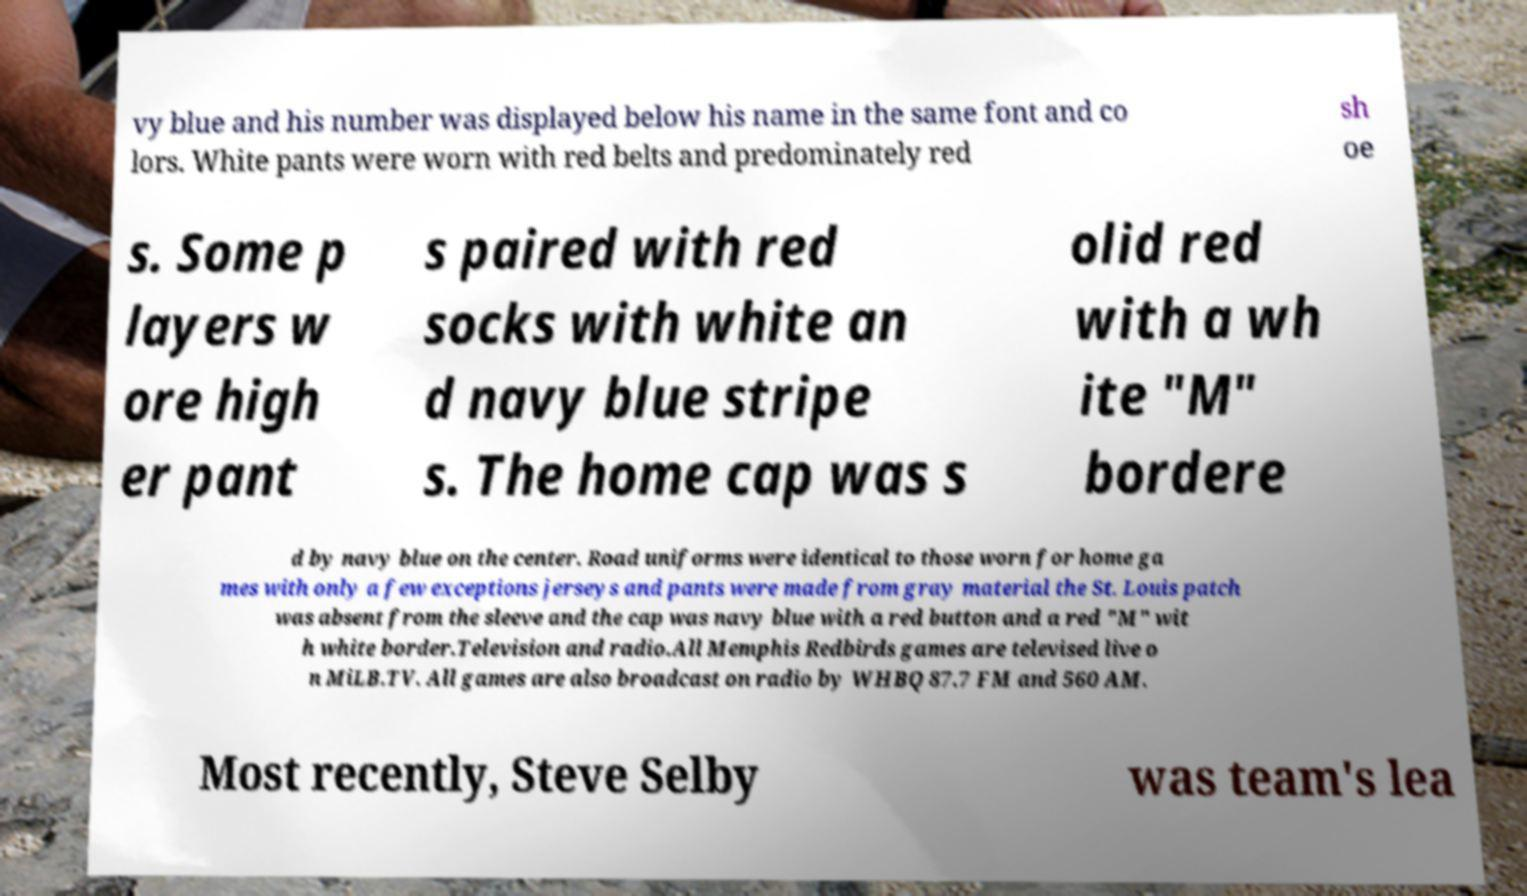Can you read and provide the text displayed in the image?This photo seems to have some interesting text. Can you extract and type it out for me? vy blue and his number was displayed below his name in the same font and co lors. White pants were worn with red belts and predominately red sh oe s. Some p layers w ore high er pant s paired with red socks with white an d navy blue stripe s. The home cap was s olid red with a wh ite "M" bordere d by navy blue on the center. Road uniforms were identical to those worn for home ga mes with only a few exceptions jerseys and pants were made from gray material the St. Louis patch was absent from the sleeve and the cap was navy blue with a red button and a red "M" wit h white border.Television and radio.All Memphis Redbirds games are televised live o n MiLB.TV. All games are also broadcast on radio by WHBQ 87.7 FM and 560 AM. Most recently, Steve Selby was team's lea 